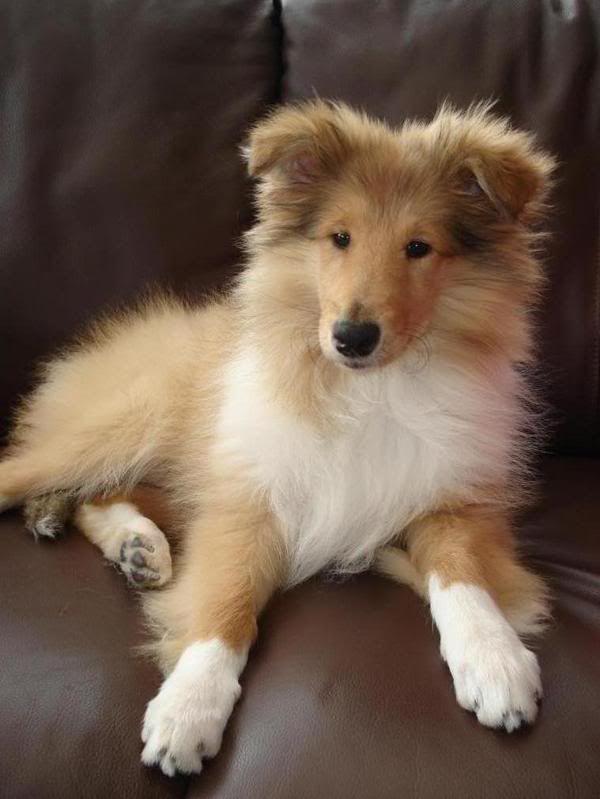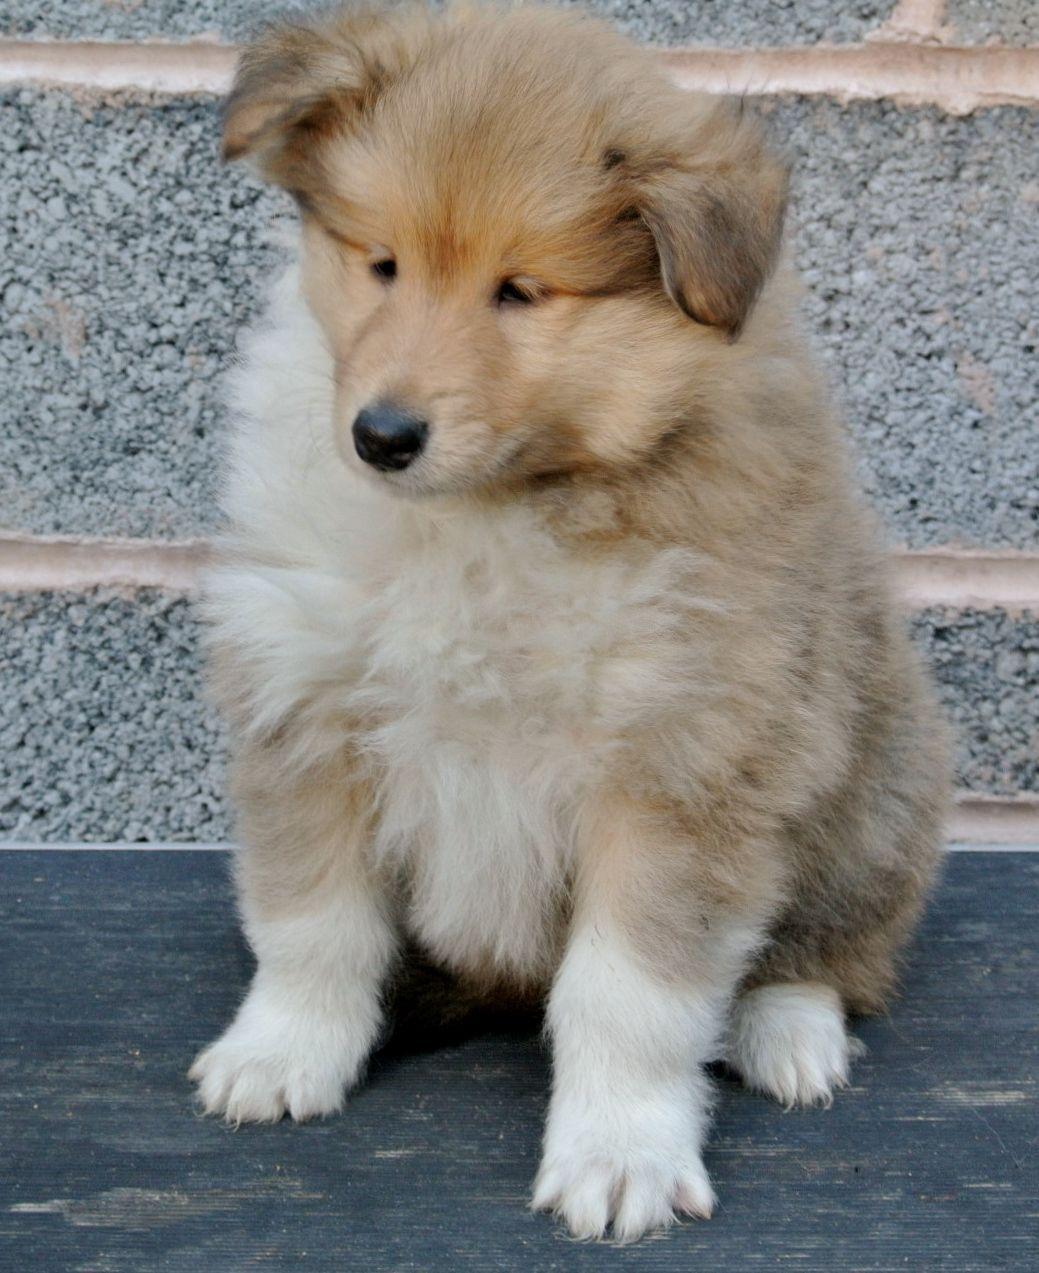The first image is the image on the left, the second image is the image on the right. Assess this claim about the two images: "there are two dogs in the image pair". Correct or not? Answer yes or no. Yes. The first image is the image on the left, the second image is the image on the right. Assess this claim about the two images: "There is dog on top of grass in one of the images.". Correct or not? Answer yes or no. No. 